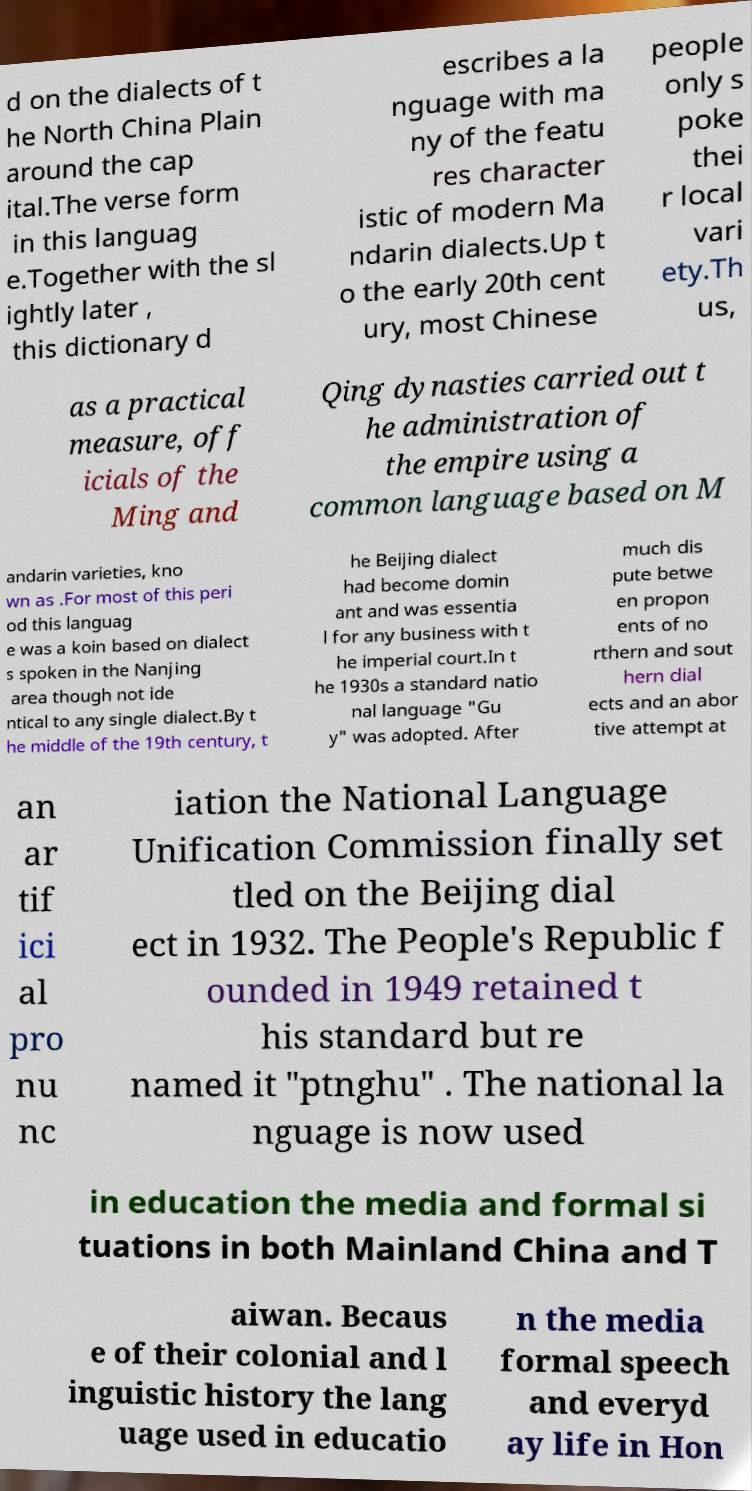Please read and relay the text visible in this image. What does it say? d on the dialects of t he North China Plain around the cap ital.The verse form in this languag e.Together with the sl ightly later , this dictionary d escribes a la nguage with ma ny of the featu res character istic of modern Ma ndarin dialects.Up t o the early 20th cent ury, most Chinese people only s poke thei r local vari ety.Th us, as a practical measure, off icials of the Ming and Qing dynasties carried out t he administration of the empire using a common language based on M andarin varieties, kno wn as .For most of this peri od this languag e was a koin based on dialect s spoken in the Nanjing area though not ide ntical to any single dialect.By t he middle of the 19th century, t he Beijing dialect had become domin ant and was essentia l for any business with t he imperial court.In t he 1930s a standard natio nal language "Gu y" was adopted. After much dis pute betwe en propon ents of no rthern and sout hern dial ects and an abor tive attempt at an ar tif ici al pro nu nc iation the National Language Unification Commission finally set tled on the Beijing dial ect in 1932. The People's Republic f ounded in 1949 retained t his standard but re named it "ptnghu" . The national la nguage is now used in education the media and formal si tuations in both Mainland China and T aiwan. Becaus e of their colonial and l inguistic history the lang uage used in educatio n the media formal speech and everyd ay life in Hon 